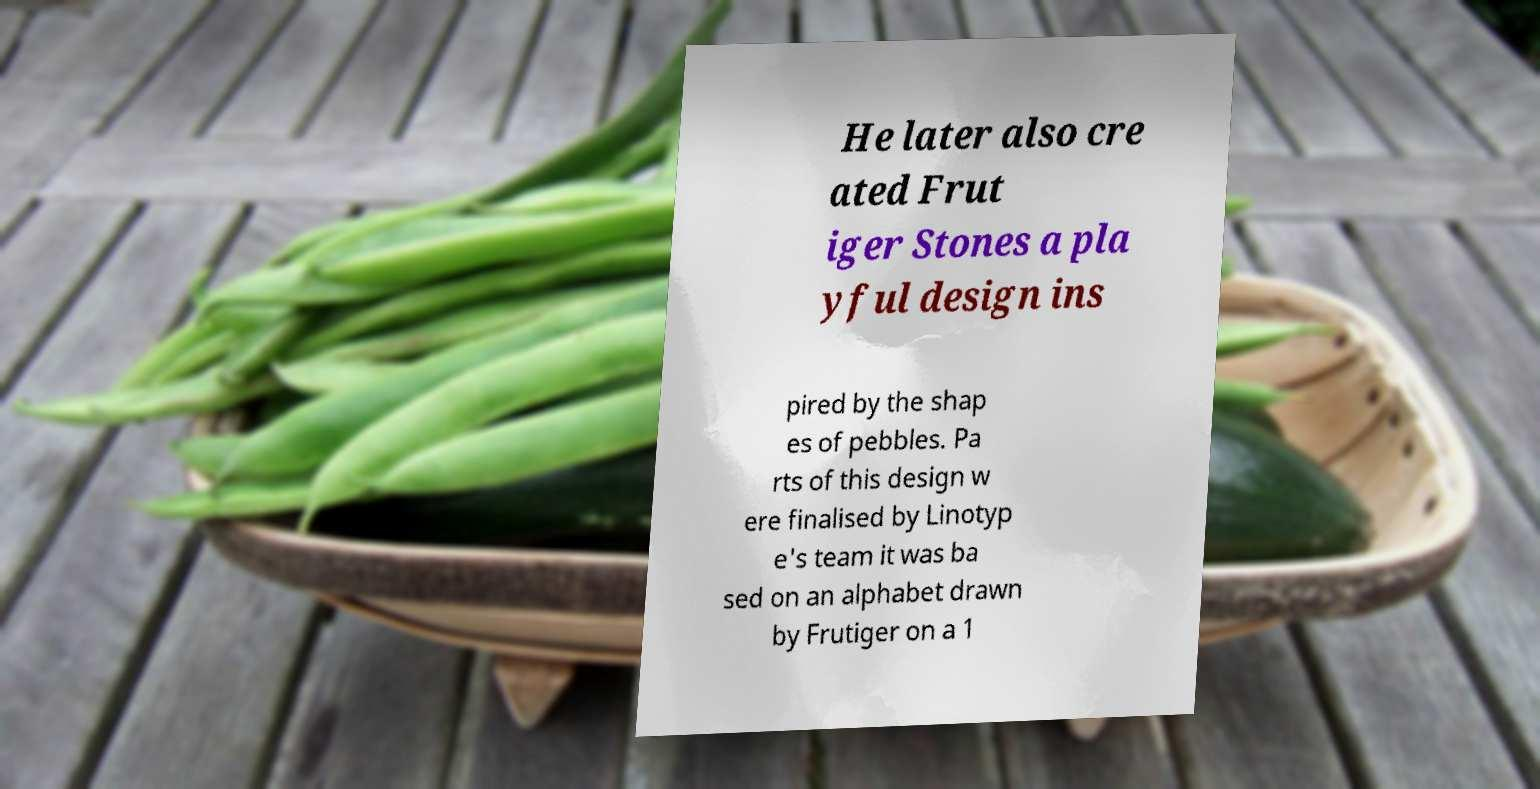What messages or text are displayed in this image? I need them in a readable, typed format. He later also cre ated Frut iger Stones a pla yful design ins pired by the shap es of pebbles. Pa rts of this design w ere finalised by Linotyp e's team it was ba sed on an alphabet drawn by Frutiger on a 1 